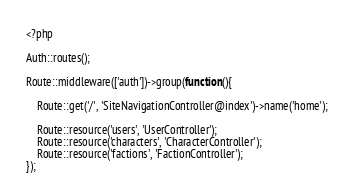<code> <loc_0><loc_0><loc_500><loc_500><_PHP_><?php

Auth::routes();

Route::middleware(['auth'])->group(function(){

    Route::get('/', 'SiteNavigationController@index')->name('home');

    Route::resource('users', 'UserController');
    Route::resource('characters', 'CharacterController');
    Route::resource('factions', 'FactionController');    
});
</code> 